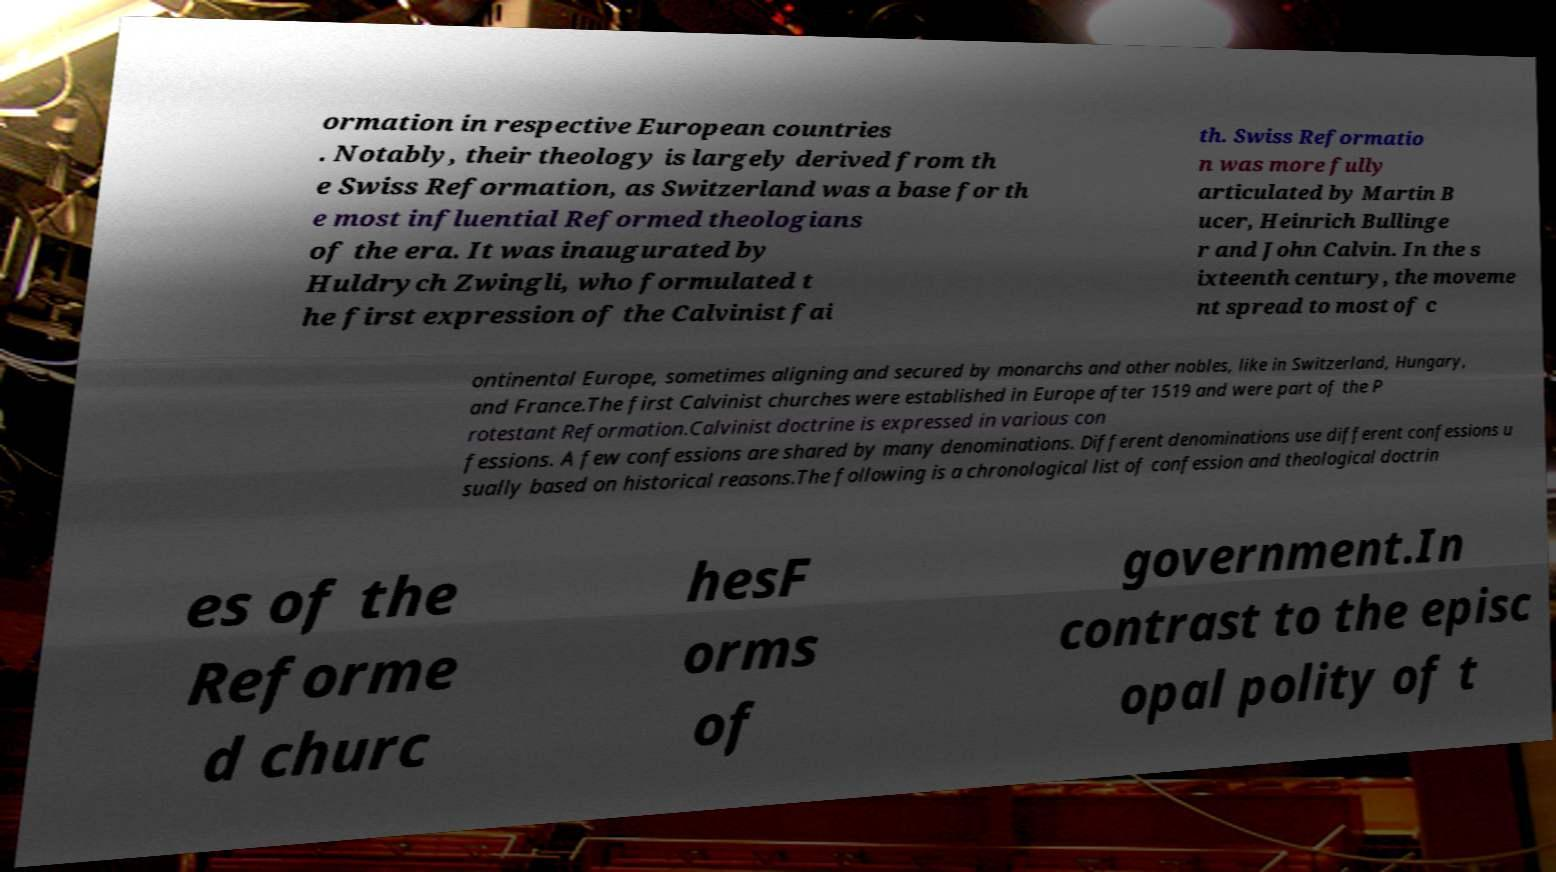Can you accurately transcribe the text from the provided image for me? ormation in respective European countries . Notably, their theology is largely derived from th e Swiss Reformation, as Switzerland was a base for th e most influential Reformed theologians of the era. It was inaugurated by Huldrych Zwingli, who formulated t he first expression of the Calvinist fai th. Swiss Reformatio n was more fully articulated by Martin B ucer, Heinrich Bullinge r and John Calvin. In the s ixteenth century, the moveme nt spread to most of c ontinental Europe, sometimes aligning and secured by monarchs and other nobles, like in Switzerland, Hungary, and France.The first Calvinist churches were established in Europe after 1519 and were part of the P rotestant Reformation.Calvinist doctrine is expressed in various con fessions. A few confessions are shared by many denominations. Different denominations use different confessions u sually based on historical reasons.The following is a chronological list of confession and theological doctrin es of the Reforme d churc hesF orms of government.In contrast to the episc opal polity of t 